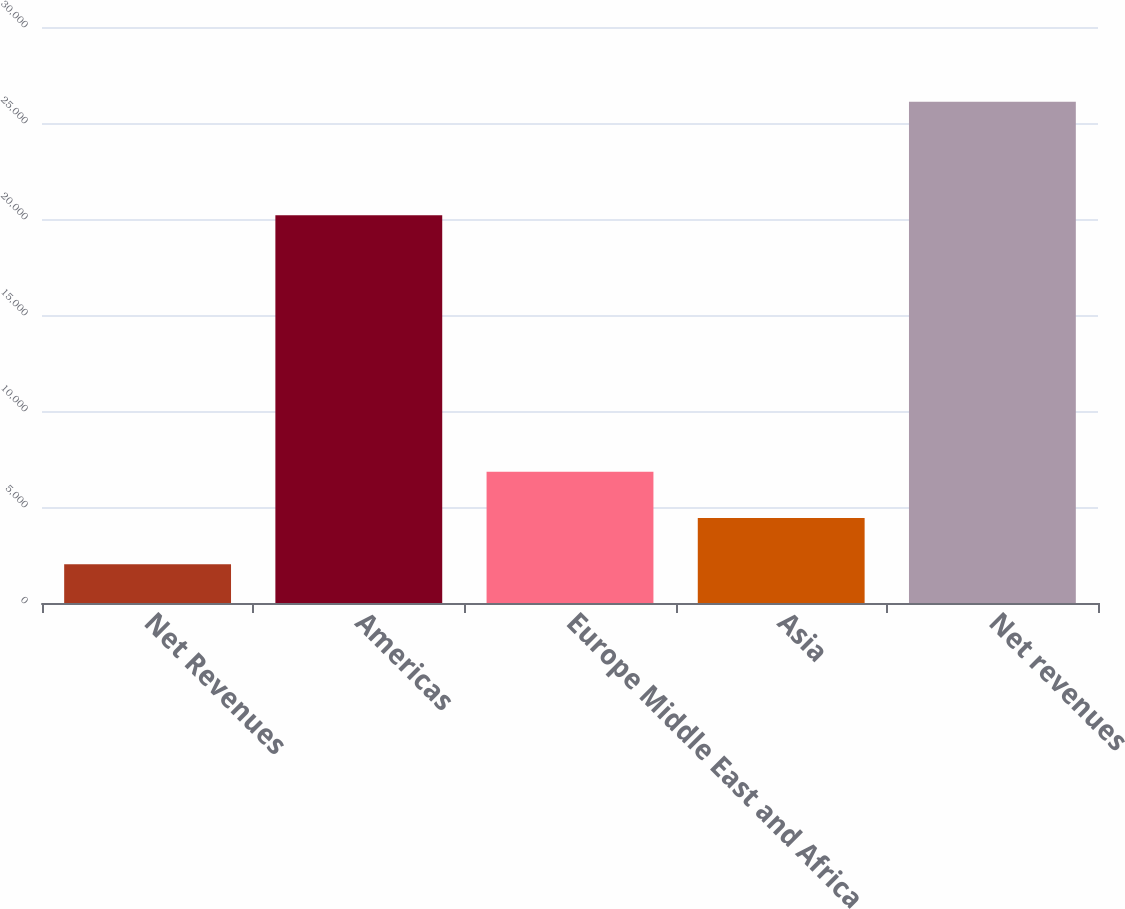Convert chart. <chart><loc_0><loc_0><loc_500><loc_500><bar_chart><fcel>Net Revenues<fcel>Americas<fcel>Europe Middle East and Africa<fcel>Asia<fcel>Net revenues<nl><fcel>2012<fcel>20200<fcel>6832<fcel>4422<fcel>26112<nl></chart> 